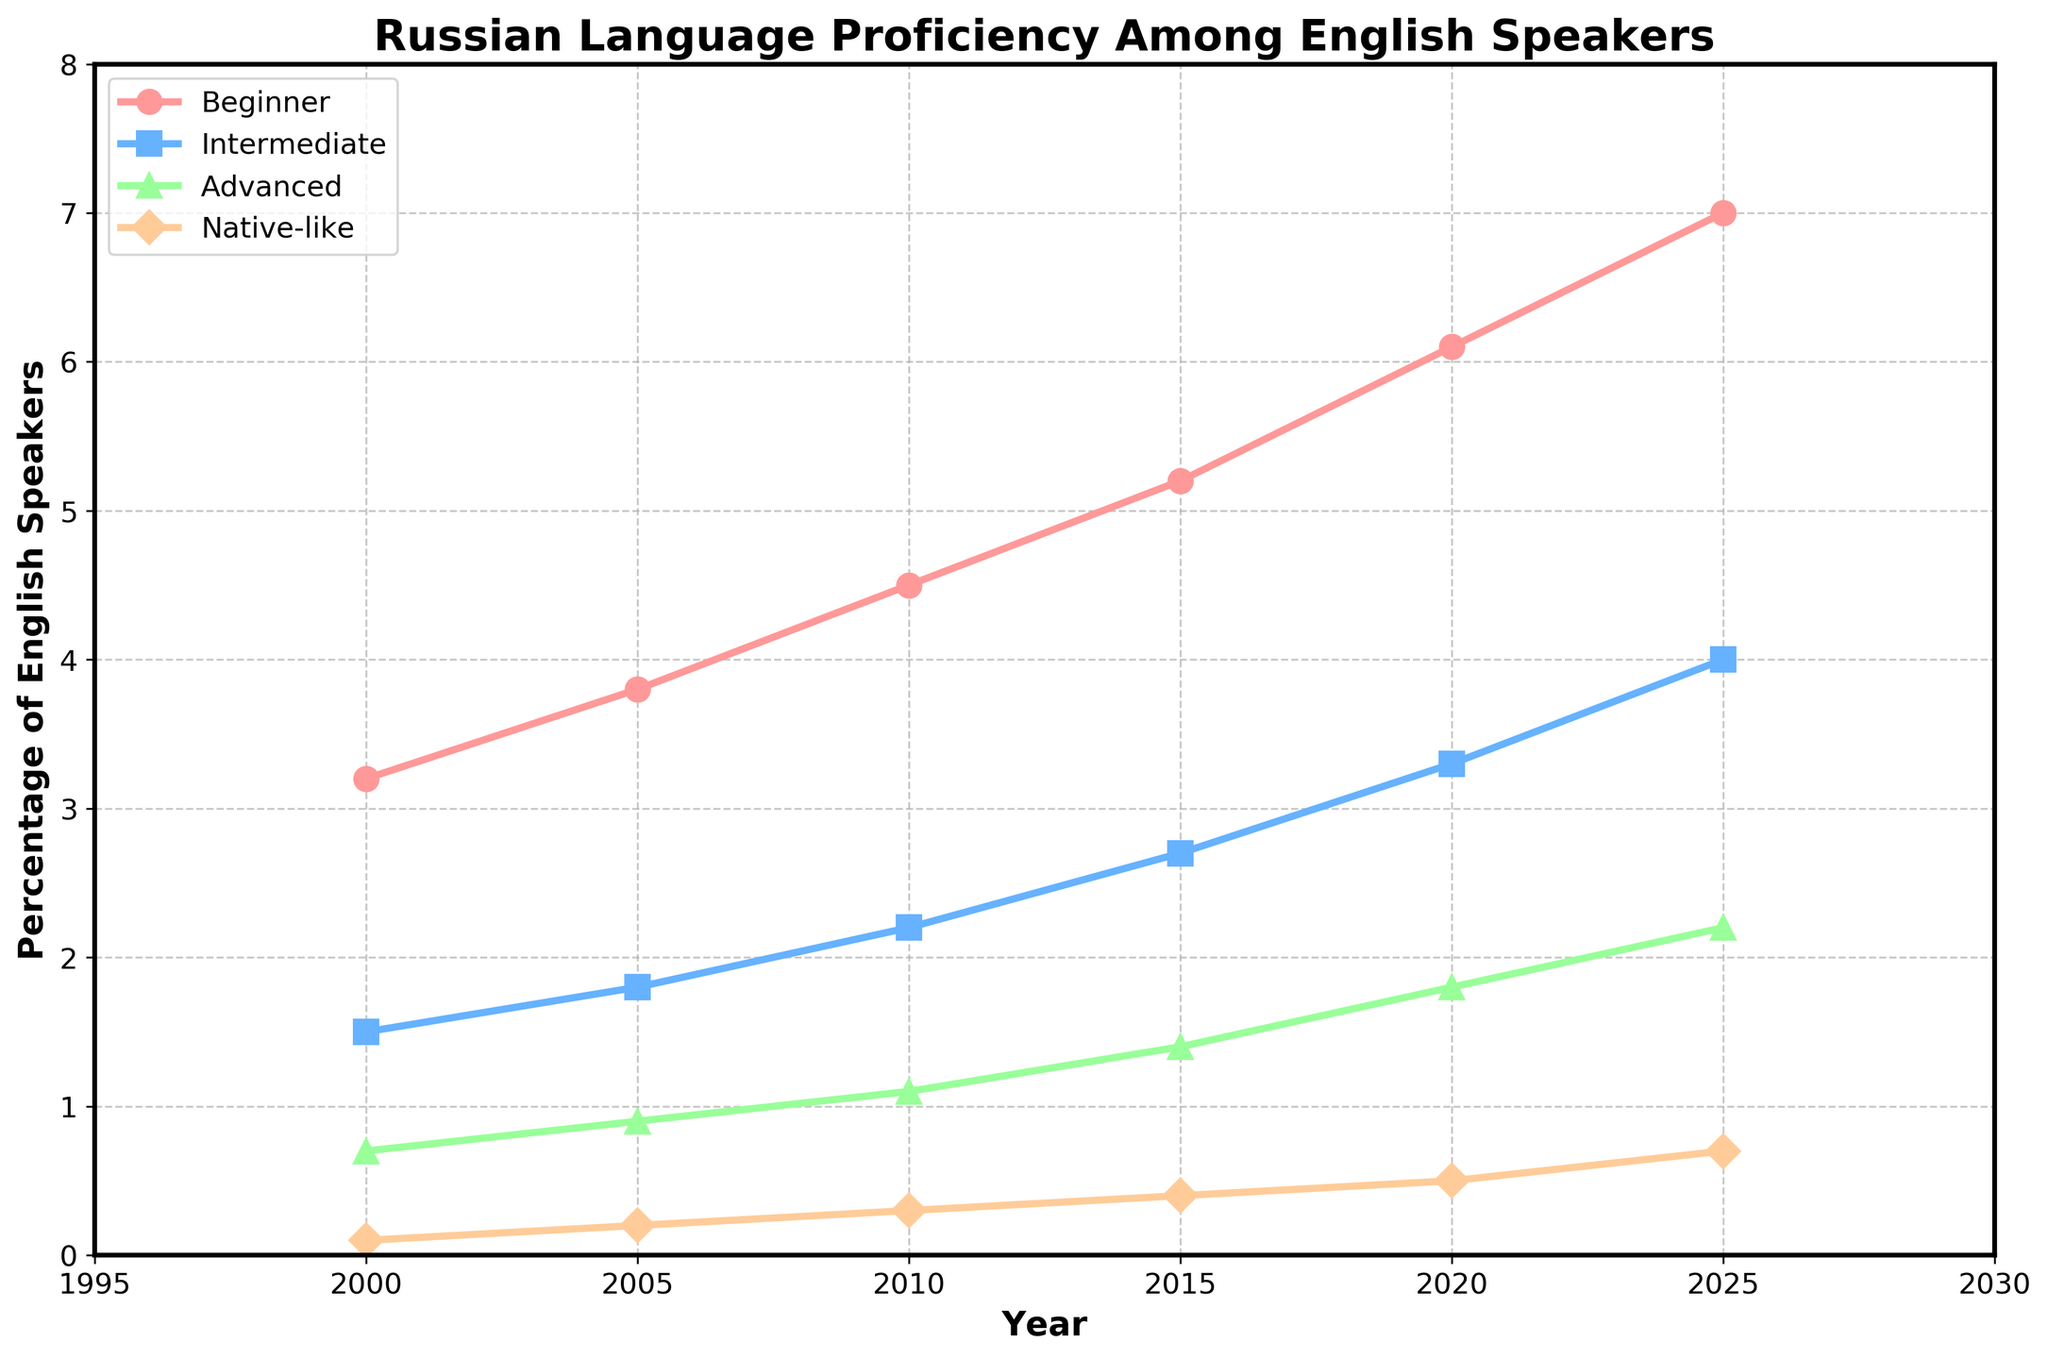Which proficiency level shows the highest increase in percentage from 2000 to 2025? The beginner proficiency level increases from 3.2% in 2000 to 7.0% in 2025, which is the highest increase among all categories.
Answer: Beginner In what year did the Intermediate proficiency level first surpass the Advanced proficiency level? In 2005, the Intermediate level is 1.8% while the Advanced level is 0.9%, showing that Intermediate surpassed Advanced for the first time.
Answer: 2005 What is the total combined percentage of English speakers with Intermediate and Advanced proficiency in 2015? In 2015, the Intermediate percentage is 2.7% and the Advanced percentage is 1.4%. Adding these: 2.7 + 1.4 = 4.1%.
Answer: 4.1% By how much did the percentage of English speakers with Native-like proficiency change between 2010 and 2020? In 2010, the percentage is 0.3% and in 2020, it is 0.5%. The change is 0.5 - 0.3 = 0.2%.
Answer: 0.2% Which proficiency level shows the smallest increase from 2000 to 2025? The Native-like proficiency level increases from 0.1% in 2000 to 0.7% in 2025, which is the smallest increase.
Answer: Native-like What was the percentage difference between Beginner and Intermediate levels in 2020? The Beginner percentage in 2020 is 6.1% and Intermediate is 3.3%. The difference is 6.1 - 3.3 = 2.8%.
Answer: 2.8% In which year did the total percentage of English speakers with Beginner and Intermediate proficiency levels reach 8.5%? In 2015, Beginner is 5.2% and Intermediate is 2.7%. Adding these: 5.2 + 2.7 = 7.9%. In 2020, Beginner is 6.1% and Intermediate is 3.3%. Adding these: 6.1 + 3.3 = 9.4%. Therefore, in 2020, the total surpassed 8.5%.
Answer: 2020 Which proficiency level consistently shows an increasing trend every year? By observing the chart, all proficiency levels show an increasing trend each year from 2000 to 2025.
Answer: All levels What is the average percentage of English speakers with Advanced proficiency from 2000 to 2025? Percentages are: 0.7, 0.9, 1.1, 1.4, 1.8, 2.2. Adding these: 0.7+0.9+1.1+1.4+1.8+2.2 = 8.1. Average: 8.1/6 = 1.35%.
Answer: 1.35% What is the proportion of Intermediate-level English speakers to the total of both Intermediate and Beginner-level in 2025? Intermediate in 2025 is 4.0% and Beginner is 7.0%. Total: 4.0 + 7.0 = 11.0%. Proportion: 4.0/11.0 = 0.3636, or 36.36%.
Answer: 36.36% 